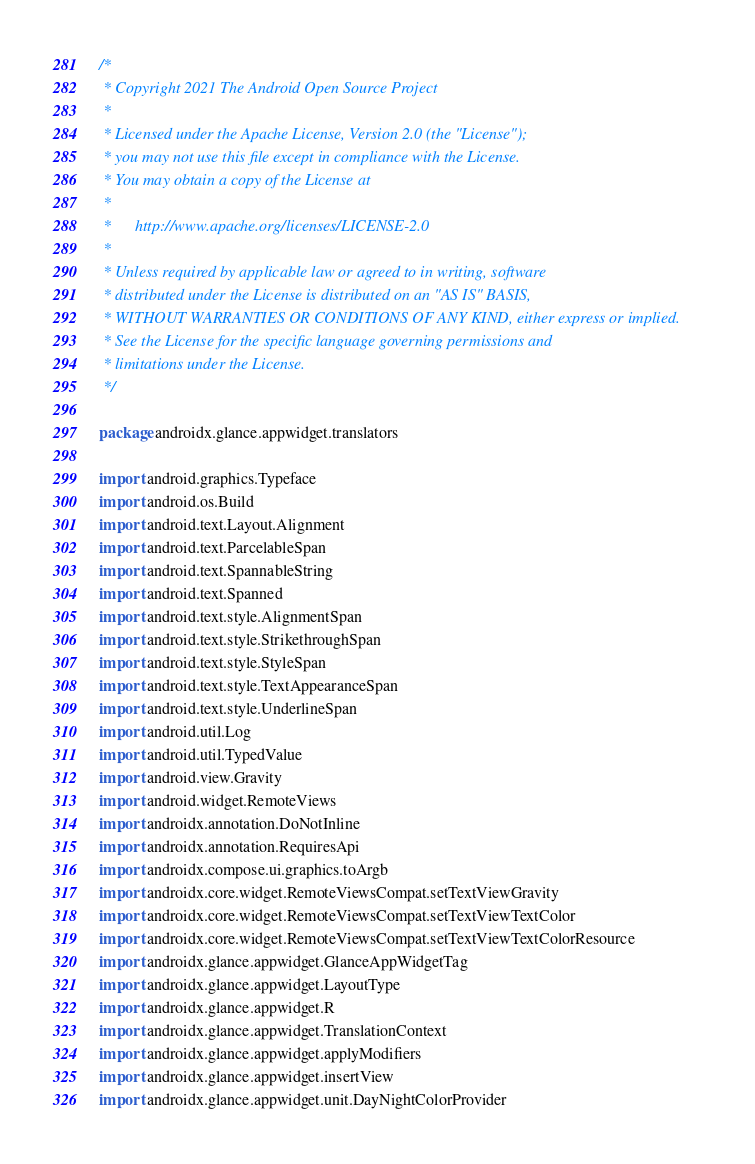<code> <loc_0><loc_0><loc_500><loc_500><_Kotlin_>/*
 * Copyright 2021 The Android Open Source Project
 *
 * Licensed under the Apache License, Version 2.0 (the "License");
 * you may not use this file except in compliance with the License.
 * You may obtain a copy of the License at
 *
 *      http://www.apache.org/licenses/LICENSE-2.0
 *
 * Unless required by applicable law or agreed to in writing, software
 * distributed under the License is distributed on an "AS IS" BASIS,
 * WITHOUT WARRANTIES OR CONDITIONS OF ANY KIND, either express or implied.
 * See the License for the specific language governing permissions and
 * limitations under the License.
 */

package androidx.glance.appwidget.translators

import android.graphics.Typeface
import android.os.Build
import android.text.Layout.Alignment
import android.text.ParcelableSpan
import android.text.SpannableString
import android.text.Spanned
import android.text.style.AlignmentSpan
import android.text.style.StrikethroughSpan
import android.text.style.StyleSpan
import android.text.style.TextAppearanceSpan
import android.text.style.UnderlineSpan
import android.util.Log
import android.util.TypedValue
import android.view.Gravity
import android.widget.RemoteViews
import androidx.annotation.DoNotInline
import androidx.annotation.RequiresApi
import androidx.compose.ui.graphics.toArgb
import androidx.core.widget.RemoteViewsCompat.setTextViewGravity
import androidx.core.widget.RemoteViewsCompat.setTextViewTextColor
import androidx.core.widget.RemoteViewsCompat.setTextViewTextColorResource
import androidx.glance.appwidget.GlanceAppWidgetTag
import androidx.glance.appwidget.LayoutType
import androidx.glance.appwidget.R
import androidx.glance.appwidget.TranslationContext
import androidx.glance.appwidget.applyModifiers
import androidx.glance.appwidget.insertView
import androidx.glance.appwidget.unit.DayNightColorProvider</code> 